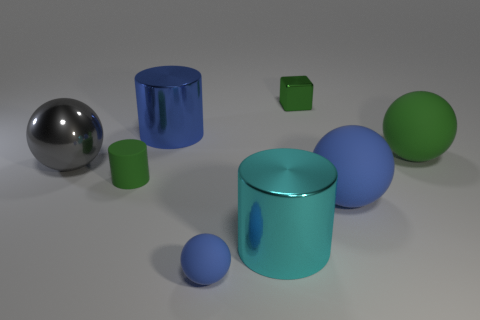Add 1 tiny green metal blocks. How many objects exist? 9 Subtract all cylinders. How many objects are left? 5 Add 5 large blue things. How many large blue things are left? 7 Add 6 small cyan shiny things. How many small cyan shiny things exist? 6 Subtract 0 yellow cubes. How many objects are left? 8 Subtract all tiny spheres. Subtract all tiny blue things. How many objects are left? 6 